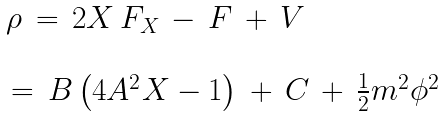Convert formula to latex. <formula><loc_0><loc_0><loc_500><loc_500>\begin{array} { l } { \rho \, = \, 2 X \, F _ { X \, } - \, F \, + \, V } \\ \\ { \, = \, B \left ( 4 A ^ { 2 } X - 1 \right ) \, + \, C \, + \, \frac { 1 } { 2 } m ^ { 2 } } \phi ^ { 2 } \end{array}</formula> 